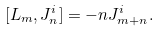<formula> <loc_0><loc_0><loc_500><loc_500>[ L _ { m } , J ^ { i } _ { n } ] = - n J ^ { i } _ { m + n } .</formula> 